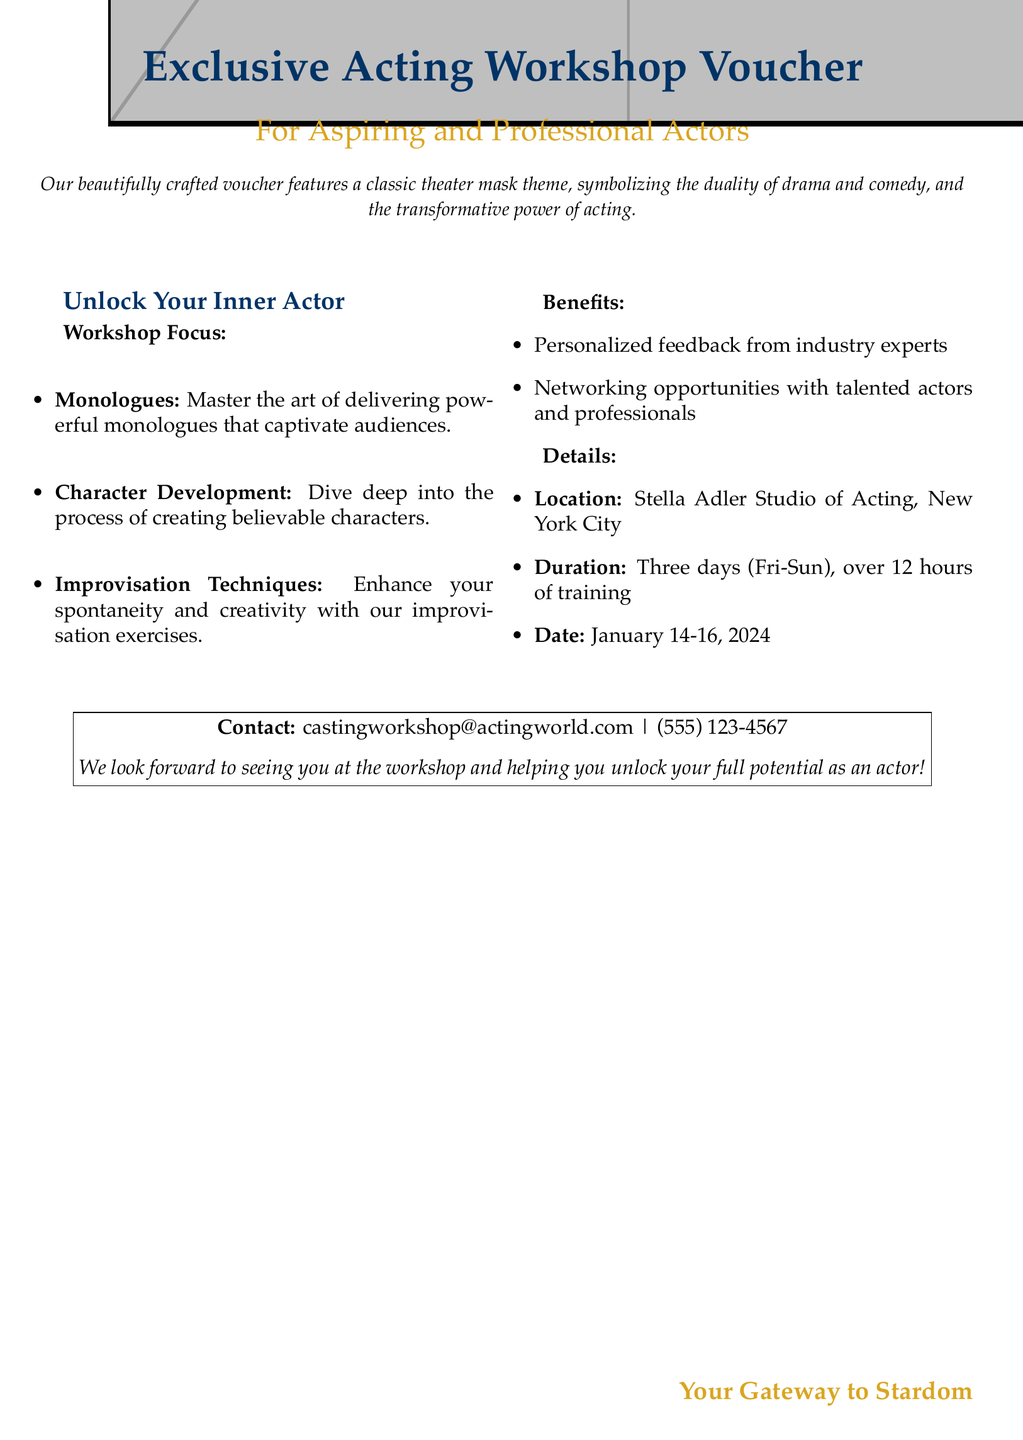What is the title of the voucher? The title is prominently displayed at the top of the document indicating the purpose of the voucher.
Answer: Exclusive Acting Workshop Voucher What is the location of the workshop? The document specifies where the workshop will be held, which is significant for participants.
Answer: Stella Adler Studio of Acting, New York City How many hours of training does the workshop offer? The document details the duration of training, which is essential for planning and scheduling.
Answer: over 12 hours What date does the workshop start? The start date is crucial for potential attendees to know when the workshop will take place.
Answer: January 14, 2024 What is one benefit of attending the workshop? The document lists specific benefits to entice potential participants to attend.
Answer: Personalized feedback from industry experts What is the theme featured on the voucher? The theme reflects the artistic nature of the workshop, which helps set the mood.
Answer: classic theater mask theme List one area of focus in the workshop. The document highlights different aspects of acting that the workshop will cover.
Answer: Monologues How many days will the workshop last? Knowing the duration helps attendees plan their time and commitments accordingly.
Answer: Three days What are networking opportunities? The document mentions this as a benefit, indicating chances for connections within the industry.
Answer: opportunities with talented actors and professionals 